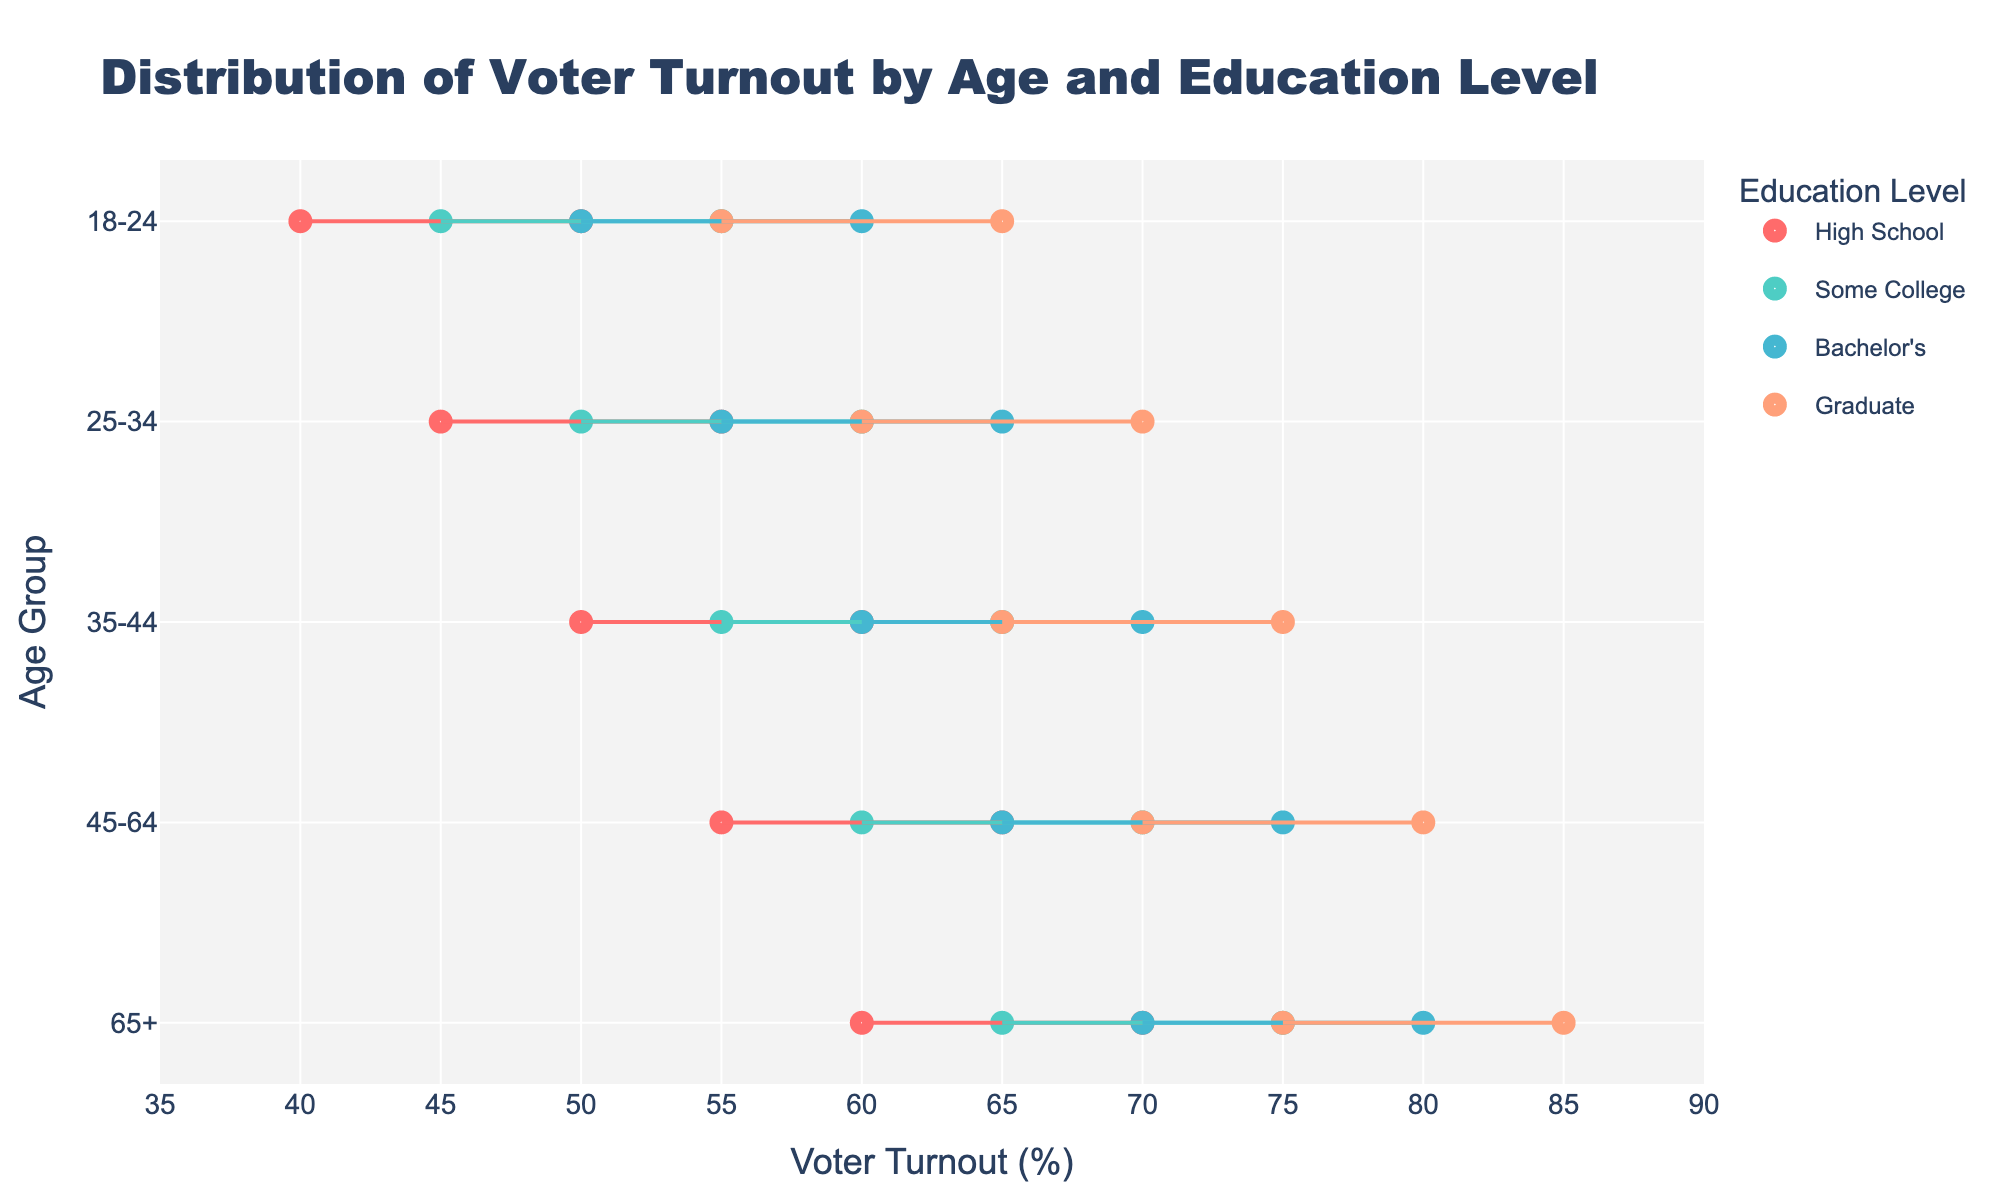What is the title of the plot? The title of the plot is located at the top of the figure and is meant to provide a summary of what the data represents. From the data and the code, we know it is "Distribution of Voter Turnout by Age and Education Level".
Answer: Distribution of Voter Turnout by Age and Education Level What is the x-axis title? The x-axis title provides information about what is measured along the horizontal axis. According to the code and the data, the x-axis title is "Voter Turnout (%)".
Answer: Voter Turnout (%) Which age group has the highest maximum voter turnout for Graduate education level? To find this, locate the maximum points for Graduate education level across different age groups. The data indicates, for "65+" with Graduate level, the maximum voter turnout is <85%, which is the highest compared to other groups.
Answer: 65+ For the 25-34 age group, which education level has the lowest minimum voter turnout? By examining the minimum points within the 25-34 age group, we find that "High School" education has a minimum voter turnout of <45%, which is the lowest compared to other educational levels in this age group.
Answer: High School Compare the voter turnout range for Bachelor’s degree holders between the 18-24 and 35-44 age groups. Which group has a wider range? For 18-24, the range is <50% to <60%, giving a width of 10 percentage points. For 35-44, the range is <60% to <70%, again a width of 10 percentage points. Both groups have the same range width.
Answer: Same range width How does voter turnout for ‘Some College’ education level change as age increases? By examining the plots for the "Some College" education level across age groups, as age increases, both minimum and maximum voter turnout percentages increase. For instance, it starts from <45-55% in the 18-24 group and goes up to <65-75% in the 65+ group.
Answer: Increases Which education level shows the smallest range in voter turnout within any age group? By comparing the range for each age group across education levels, the "Graduate" level for the 65+ group has the smallest range, which is from <75% to <85%, a range of 10 percentage points.
Answer: Graduate for 65+ What is the average maximum voter turnout for the Graduate level across all age groups? Sum the maximum voter turnout percentages for all age groups for the Graduate level: 65+ (<85%), 45-64 (<80%), 35-44 (<75%), 25-34 (<70%), 18-24 (<65%). Calculate the average: (85 + 80 + 75 + 70 + 65) / 5 = 75.
Answer: 75 Which age group has the least variation in voter turnout for High School education level? Look at the range (difference between maximum and minimum) for the "High School" level across age groups: 18-24 (<40-50), 25-34 (<45-55), 35-44 (<50-60), 45-64 (<55-65), and 65+ (<60-70). All ranges are 10 percentage points, hence they all have the same variation.
Answer: All same In the 45-64 age group, which education level has the highest minimum voter turnout? In the 45-64 group, by checking the minimum voter turnout for each education level, "Graduate" has the highest minimum turnout at <70%.
Answer: Graduate 